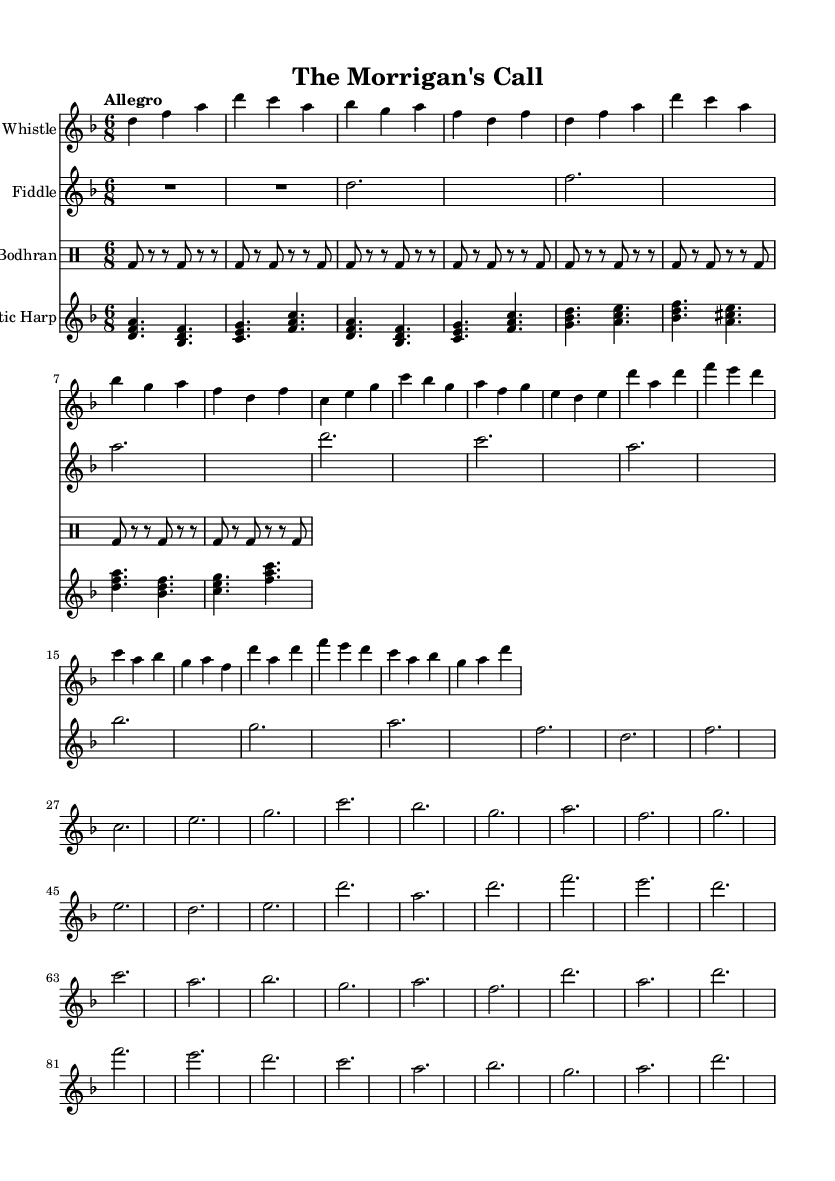What is the time signature of this music? The time signature is indicated at the beginning of the sheet music as 6/8, which means there are six eighth notes per measure.
Answer: 6/8 What is the key signature of this music? The key signature is D minor, which is indicated by one flat (B flat) in the key signature area.
Answer: D minor What is the tempo marking for this piece? The tempo marking is provided as "Allegro," which indicates a fast tempo, typically around 120-168 beats per minute.
Answer: Allegro What instruments are featured in this score? The sheet music includes four instruments: Tin Whistle, Fiddle, Bodhran, and Celtic Harp, each represented by a separate staff in the score.
Answer: Tin Whistle, Fiddle, Bodhran, Celtic Harp How many measures are in the verse section? The verse section consists of four measures, which can be counted by examining the repeated phrases and the structure of the music.
Answer: 4 What musical elements are characteristic of Celtic folk music in this piece? The piece features characteristics typical of Celtic folk music, such as a 6/8 time signature, use of traditional instruments (e.g., fiddle, harp), and the incorporation of modal harmony reflecting ancient myths.
Answer: Traditional rhythms and modal harmony What type of feet does the Bodhran rhythm use? The Bodhran rhythm uses a pattern of accented beats and rests, creating a driving pulse typical in Celtic music, often played with varying dynamics.
Answer: Accented beats 